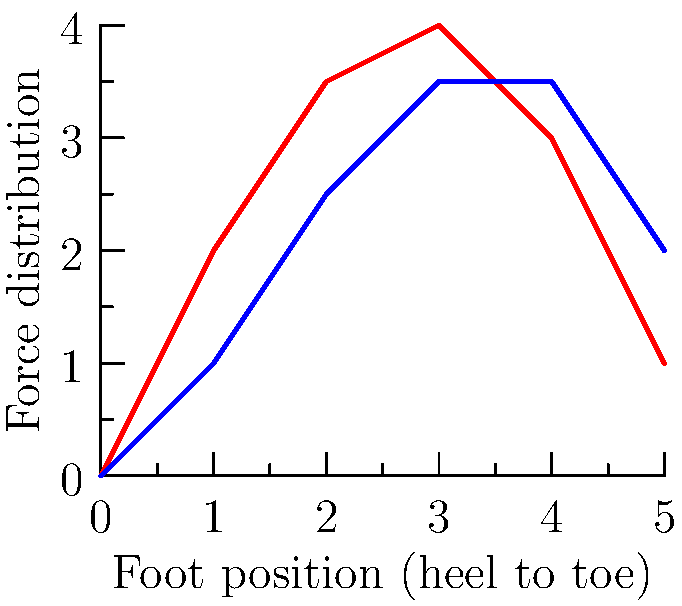Based on the force distribution graph comparing traditional and modern athletic shoes, which type of shoe appears to provide better force absorption in the heel area, and how might this impact an athlete's performance in high-impact activities? To answer this question, let's analyze the graph step-by-step:

1. Observe the curves:
   - Red curve represents traditional shoes
   - Blue curve represents modern shoes

2. Compare heel area (left side of the graph):
   - Traditional shoes show a higher peak at the heel
   - Modern shoes have a lower, more gradual increase

3. Interpret the difference:
   - Higher peak in traditional shoes indicates more concentrated force on the heel
   - Lower, gradual increase in modern shoes suggests better force distribution and absorption

4. Impact on performance:
   - Better force absorption in modern shoes can reduce the risk of heel-related injuries
   - Improved shock absorption may lead to less fatigue during high-impact activities
   - More even force distribution could contribute to better overall foot stability

5. Consider the midfoot and forefoot areas:
   - Modern shoes maintain a higher force distribution in these areas
   - This could indicate better energy return and propulsion in modern shoes

6. Overall implication:
   - Modern shoes appear to offer a more balanced force distribution throughout the entire foot
   - This may lead to improved performance in activities requiring both impact absorption and explosive movements

Based on this analysis, modern athletic shoes seem to provide better force absorption in the heel area, which could potentially enhance an athlete's performance and reduce injury risk in high-impact activities.
Answer: Modern shoes; better heel impact absorption and overall force distribution can enhance performance and reduce injury risk. 